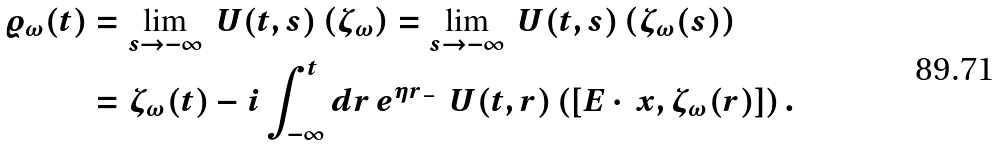Convert formula to latex. <formula><loc_0><loc_0><loc_500><loc_500>\varrho _ { \omega } ( t ) & = \lim _ { s \to - \infty } { \ U } ( t , s ) \left ( { \zeta } _ { \omega } \right ) = \lim _ { s \to - \infty } { \ U } ( t , s ) \left ( { \zeta } _ { \omega } ( s ) \right ) \\ & = { \zeta } _ { \omega } ( t ) - i \int _ { - \infty } ^ { t } d r \, e ^ { \eta { r _ { \, - } } } { \, \ U } ( t , r ) \left ( [ E \cdot \ x , { \zeta } _ { \omega } ( r ) ] \right ) .</formula> 